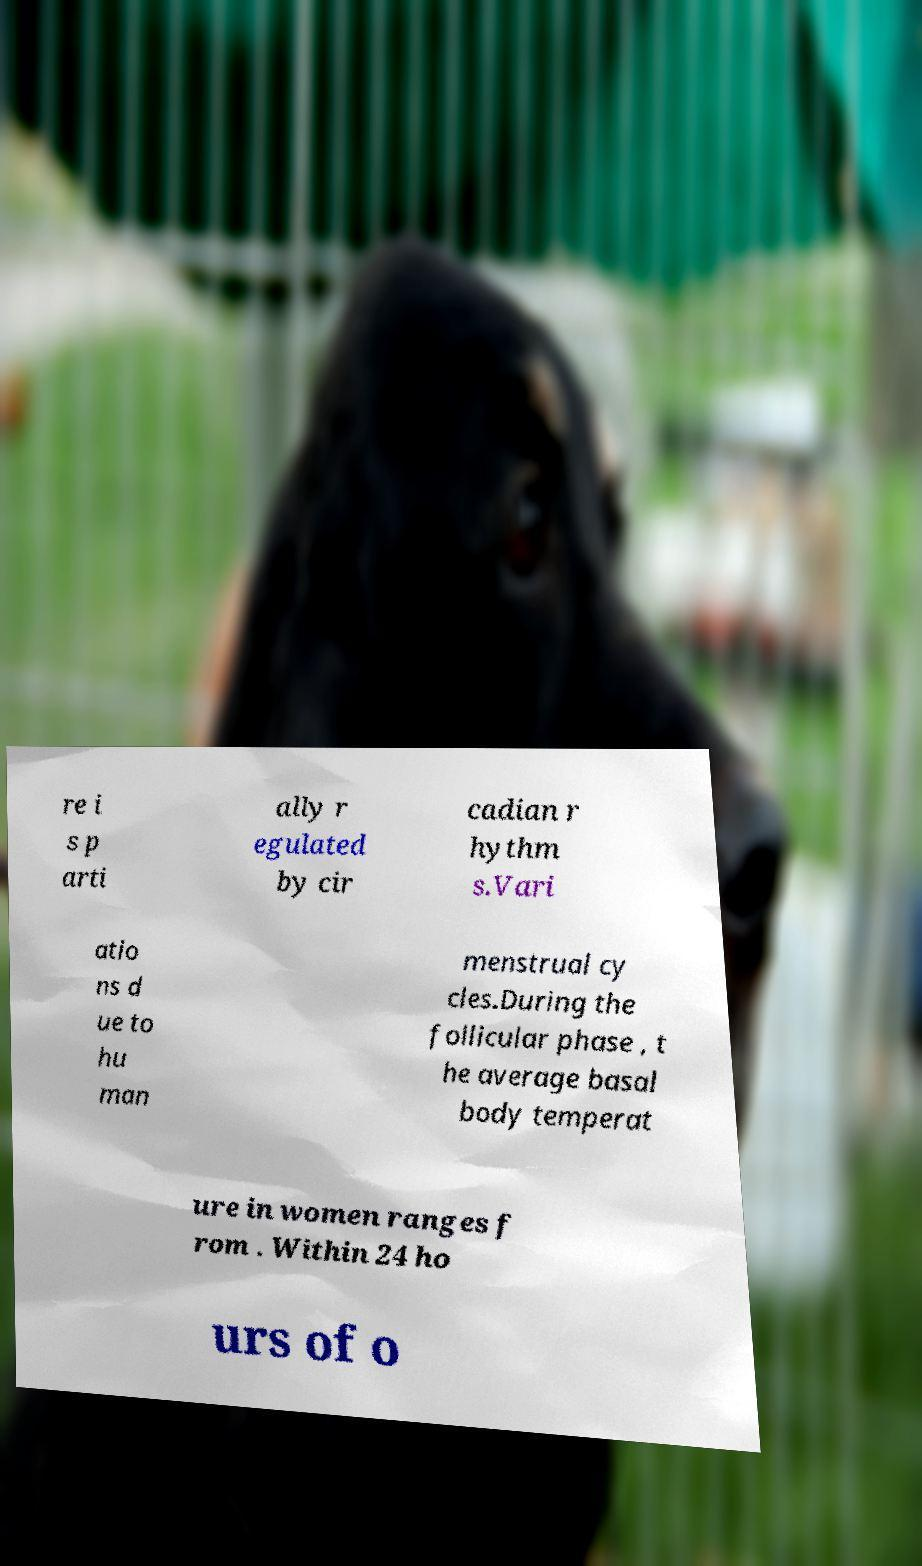Can you read and provide the text displayed in the image?This photo seems to have some interesting text. Can you extract and type it out for me? re i s p arti ally r egulated by cir cadian r hythm s.Vari atio ns d ue to hu man menstrual cy cles.During the follicular phase , t he average basal body temperat ure in women ranges f rom . Within 24 ho urs of o 